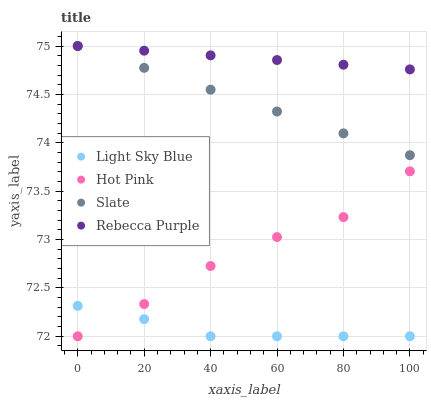Does Light Sky Blue have the minimum area under the curve?
Answer yes or no. Yes. Does Rebecca Purple have the maximum area under the curve?
Answer yes or no. Yes. Does Rebecca Purple have the minimum area under the curve?
Answer yes or no. No. Does Light Sky Blue have the maximum area under the curve?
Answer yes or no. No. Is Slate the smoothest?
Answer yes or no. Yes. Is Hot Pink the roughest?
Answer yes or no. Yes. Is Light Sky Blue the smoothest?
Answer yes or no. No. Is Light Sky Blue the roughest?
Answer yes or no. No. Does Light Sky Blue have the lowest value?
Answer yes or no. Yes. Does Rebecca Purple have the lowest value?
Answer yes or no. No. Does Rebecca Purple have the highest value?
Answer yes or no. Yes. Does Light Sky Blue have the highest value?
Answer yes or no. No. Is Hot Pink less than Rebecca Purple?
Answer yes or no. Yes. Is Rebecca Purple greater than Light Sky Blue?
Answer yes or no. Yes. Does Slate intersect Rebecca Purple?
Answer yes or no. Yes. Is Slate less than Rebecca Purple?
Answer yes or no. No. Is Slate greater than Rebecca Purple?
Answer yes or no. No. Does Hot Pink intersect Rebecca Purple?
Answer yes or no. No. 